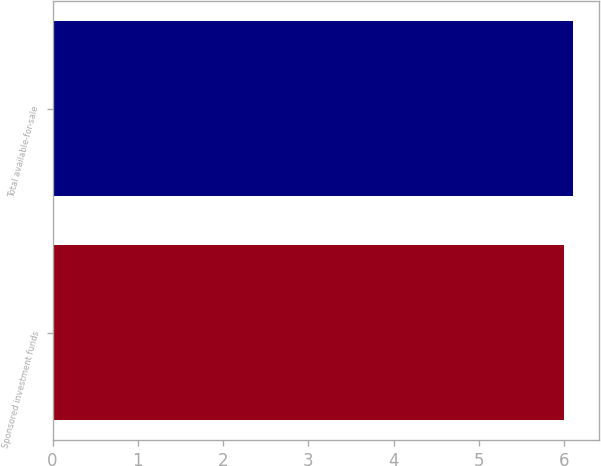Convert chart to OTSL. <chart><loc_0><loc_0><loc_500><loc_500><bar_chart><fcel>Sponsored investment funds<fcel>Total available-for-sale<nl><fcel>6<fcel>6.1<nl></chart> 